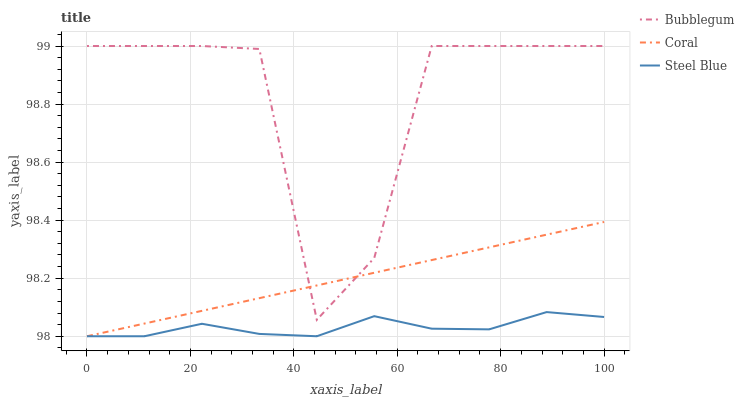Does Steel Blue have the minimum area under the curve?
Answer yes or no. Yes. Does Bubblegum have the maximum area under the curve?
Answer yes or no. Yes. Does Bubblegum have the minimum area under the curve?
Answer yes or no. No. Does Steel Blue have the maximum area under the curve?
Answer yes or no. No. Is Coral the smoothest?
Answer yes or no. Yes. Is Bubblegum the roughest?
Answer yes or no. Yes. Is Steel Blue the smoothest?
Answer yes or no. No. Is Steel Blue the roughest?
Answer yes or no. No. Does Coral have the lowest value?
Answer yes or no. Yes. Does Bubblegum have the lowest value?
Answer yes or no. No. Does Bubblegum have the highest value?
Answer yes or no. Yes. Does Steel Blue have the highest value?
Answer yes or no. No. Is Steel Blue less than Bubblegum?
Answer yes or no. Yes. Is Bubblegum greater than Steel Blue?
Answer yes or no. Yes. Does Coral intersect Bubblegum?
Answer yes or no. Yes. Is Coral less than Bubblegum?
Answer yes or no. No. Is Coral greater than Bubblegum?
Answer yes or no. No. Does Steel Blue intersect Bubblegum?
Answer yes or no. No. 